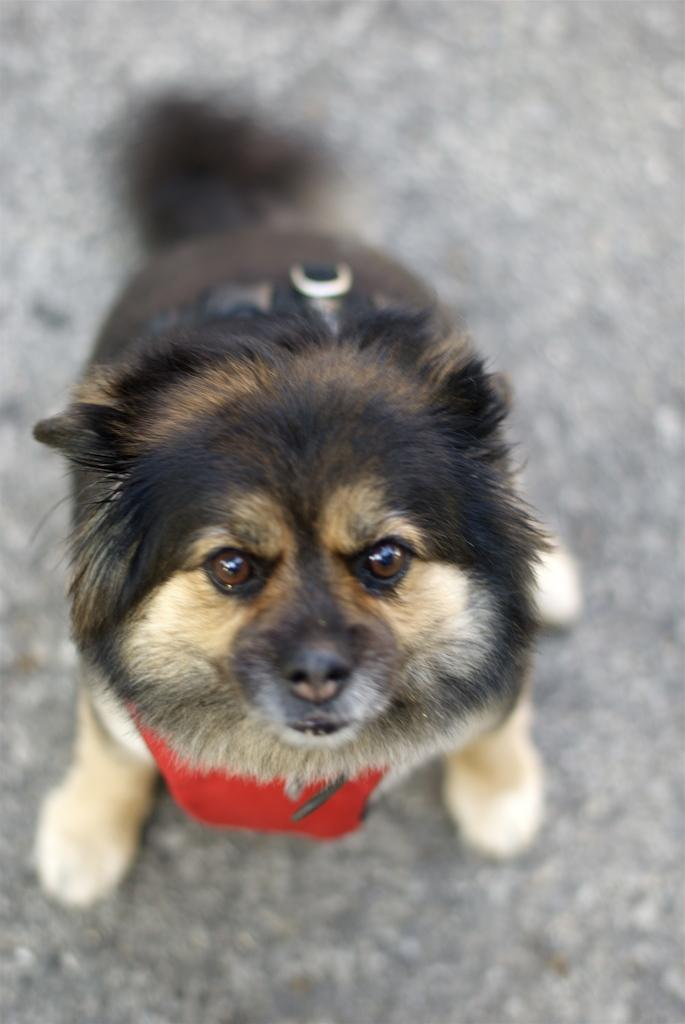What is the main subject in the foreground of the image? There is a dog in the foreground of the image. What can be seen in the background of the image? There is a road visible in the background of the image. What type of cork can be seen in the dog's mouth in the image? There is no cork present in the image, and the dog's mouth is not visible. 